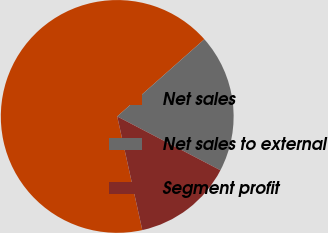<chart> <loc_0><loc_0><loc_500><loc_500><pie_chart><fcel>Net sales<fcel>Net sales to external<fcel>Segment profit<nl><fcel>66.92%<fcel>19.19%<fcel>13.89%<nl></chart> 